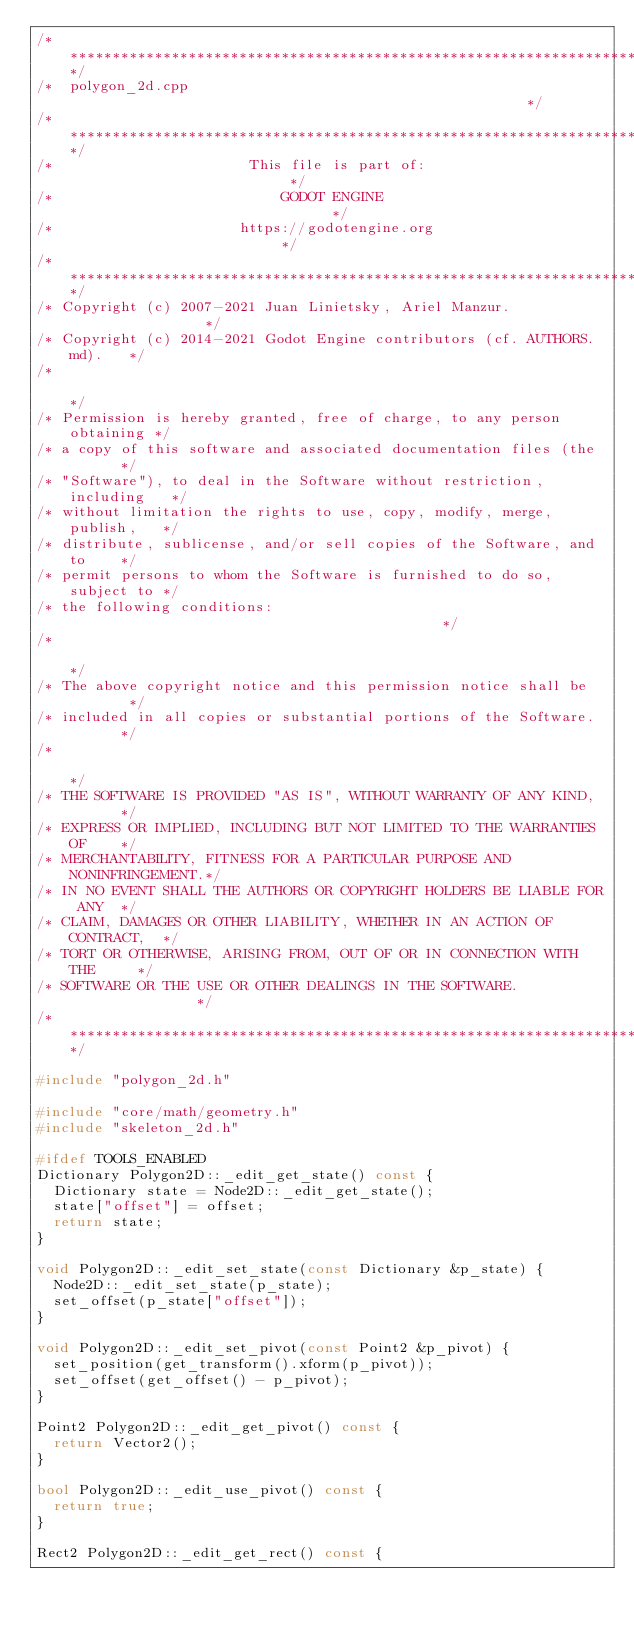<code> <loc_0><loc_0><loc_500><loc_500><_C++_>/*************************************************************************/
/*  polygon_2d.cpp                                                       */
/*************************************************************************/
/*                       This file is part of:                           */
/*                           GODOT ENGINE                                */
/*                      https://godotengine.org                          */
/*************************************************************************/
/* Copyright (c) 2007-2021 Juan Linietsky, Ariel Manzur.                 */
/* Copyright (c) 2014-2021 Godot Engine contributors (cf. AUTHORS.md).   */
/*                                                                       */
/* Permission is hereby granted, free of charge, to any person obtaining */
/* a copy of this software and associated documentation files (the       */
/* "Software"), to deal in the Software without restriction, including   */
/* without limitation the rights to use, copy, modify, merge, publish,   */
/* distribute, sublicense, and/or sell copies of the Software, and to    */
/* permit persons to whom the Software is furnished to do so, subject to */
/* the following conditions:                                             */
/*                                                                       */
/* The above copyright notice and this permission notice shall be        */
/* included in all copies or substantial portions of the Software.       */
/*                                                                       */
/* THE SOFTWARE IS PROVIDED "AS IS", WITHOUT WARRANTY OF ANY KIND,       */
/* EXPRESS OR IMPLIED, INCLUDING BUT NOT LIMITED TO THE WARRANTIES OF    */
/* MERCHANTABILITY, FITNESS FOR A PARTICULAR PURPOSE AND NONINFRINGEMENT.*/
/* IN NO EVENT SHALL THE AUTHORS OR COPYRIGHT HOLDERS BE LIABLE FOR ANY  */
/* CLAIM, DAMAGES OR OTHER LIABILITY, WHETHER IN AN ACTION OF CONTRACT,  */
/* TORT OR OTHERWISE, ARISING FROM, OUT OF OR IN CONNECTION WITH THE     */
/* SOFTWARE OR THE USE OR OTHER DEALINGS IN THE SOFTWARE.                */
/*************************************************************************/

#include "polygon_2d.h"

#include "core/math/geometry.h"
#include "skeleton_2d.h"

#ifdef TOOLS_ENABLED
Dictionary Polygon2D::_edit_get_state() const {
	Dictionary state = Node2D::_edit_get_state();
	state["offset"] = offset;
	return state;
}

void Polygon2D::_edit_set_state(const Dictionary &p_state) {
	Node2D::_edit_set_state(p_state);
	set_offset(p_state["offset"]);
}

void Polygon2D::_edit_set_pivot(const Point2 &p_pivot) {
	set_position(get_transform().xform(p_pivot));
	set_offset(get_offset() - p_pivot);
}

Point2 Polygon2D::_edit_get_pivot() const {
	return Vector2();
}

bool Polygon2D::_edit_use_pivot() const {
	return true;
}

Rect2 Polygon2D::_edit_get_rect() const {</code> 